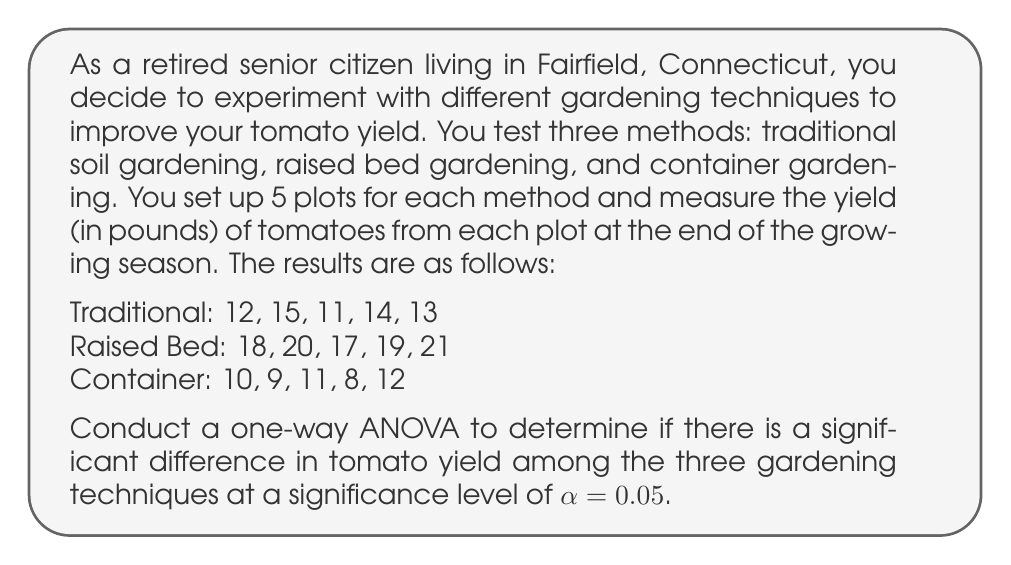Show me your answer to this math problem. To conduct a one-way ANOVA, we'll follow these steps:

1. Calculate the sum of squares between groups (SSB), within groups (SSW), and total (SST).
2. Calculate the degrees of freedom for between groups (dfB), within groups (dfW), and total (dfT).
3. Calculate the mean squares for between groups (MSB) and within groups (MSW).
4. Calculate the F-statistic.
5. Compare the F-statistic to the critical F-value.

Step 1: Calculate sum of squares

First, we need to calculate the grand mean:
$$\bar{X} = \frac{12 + 15 + 11 + 14 + 13 + 18 + 20 + 17 + 19 + 21 + 10 + 9 + 11 + 8 + 12}{15} = 14$$

Now, we can calculate SSB, SSW, and SST:

SSB:
$$SSB = 5[(13 - 14)^2 + (19 - 14)^2 + (10 - 14)^2] = 270$$

SSW:
$$SSW = [(12-13)^2 + (15-13)^2 + (11-13)^2 + (14-13)^2 + (13-13)^2] +$$
$$[(18-19)^2 + (20-19)^2 + (17-19)^2 + (19-19)^2 + (21-19)^2] +$$
$$[(10-10)^2 + (9-10)^2 + (11-10)^2 + (8-10)^2 + (12-10)^2] = 44$$

SST:
$$SST = SSB + SSW = 270 + 44 = 314$$

Step 2: Calculate degrees of freedom

dfB = number of groups - 1 = 3 - 1 = 2
dfW = total number of observations - number of groups = 15 - 3 = 12
dfT = total number of observations - 1 = 15 - 1 = 14

Step 3: Calculate mean squares

$$MSB = \frac{SSB}{dfB} = \frac{270}{2} = 135$$
$$MSW = \frac{SSW}{dfW} = \frac{44}{12} = 3.67$$

Step 4: Calculate F-statistic

$$F = \frac{MSB}{MSW} = \frac{135}{3.67} = 36.78$$

Step 5: Compare F-statistic to critical F-value

The critical F-value for $\alpha = 0.05$, dfB = 2, and dfW = 12 is approximately 3.89 (from F-distribution table).

Since our calculated F-statistic (36.78) is greater than the critical F-value (3.89), we reject the null hypothesis.
Answer: There is a significant difference in tomato yield among the three gardening techniques (F(2, 12) = 36.78, p < 0.05). We reject the null hypothesis and conclude that at least one gardening technique produces a significantly different yield compared to the others. 